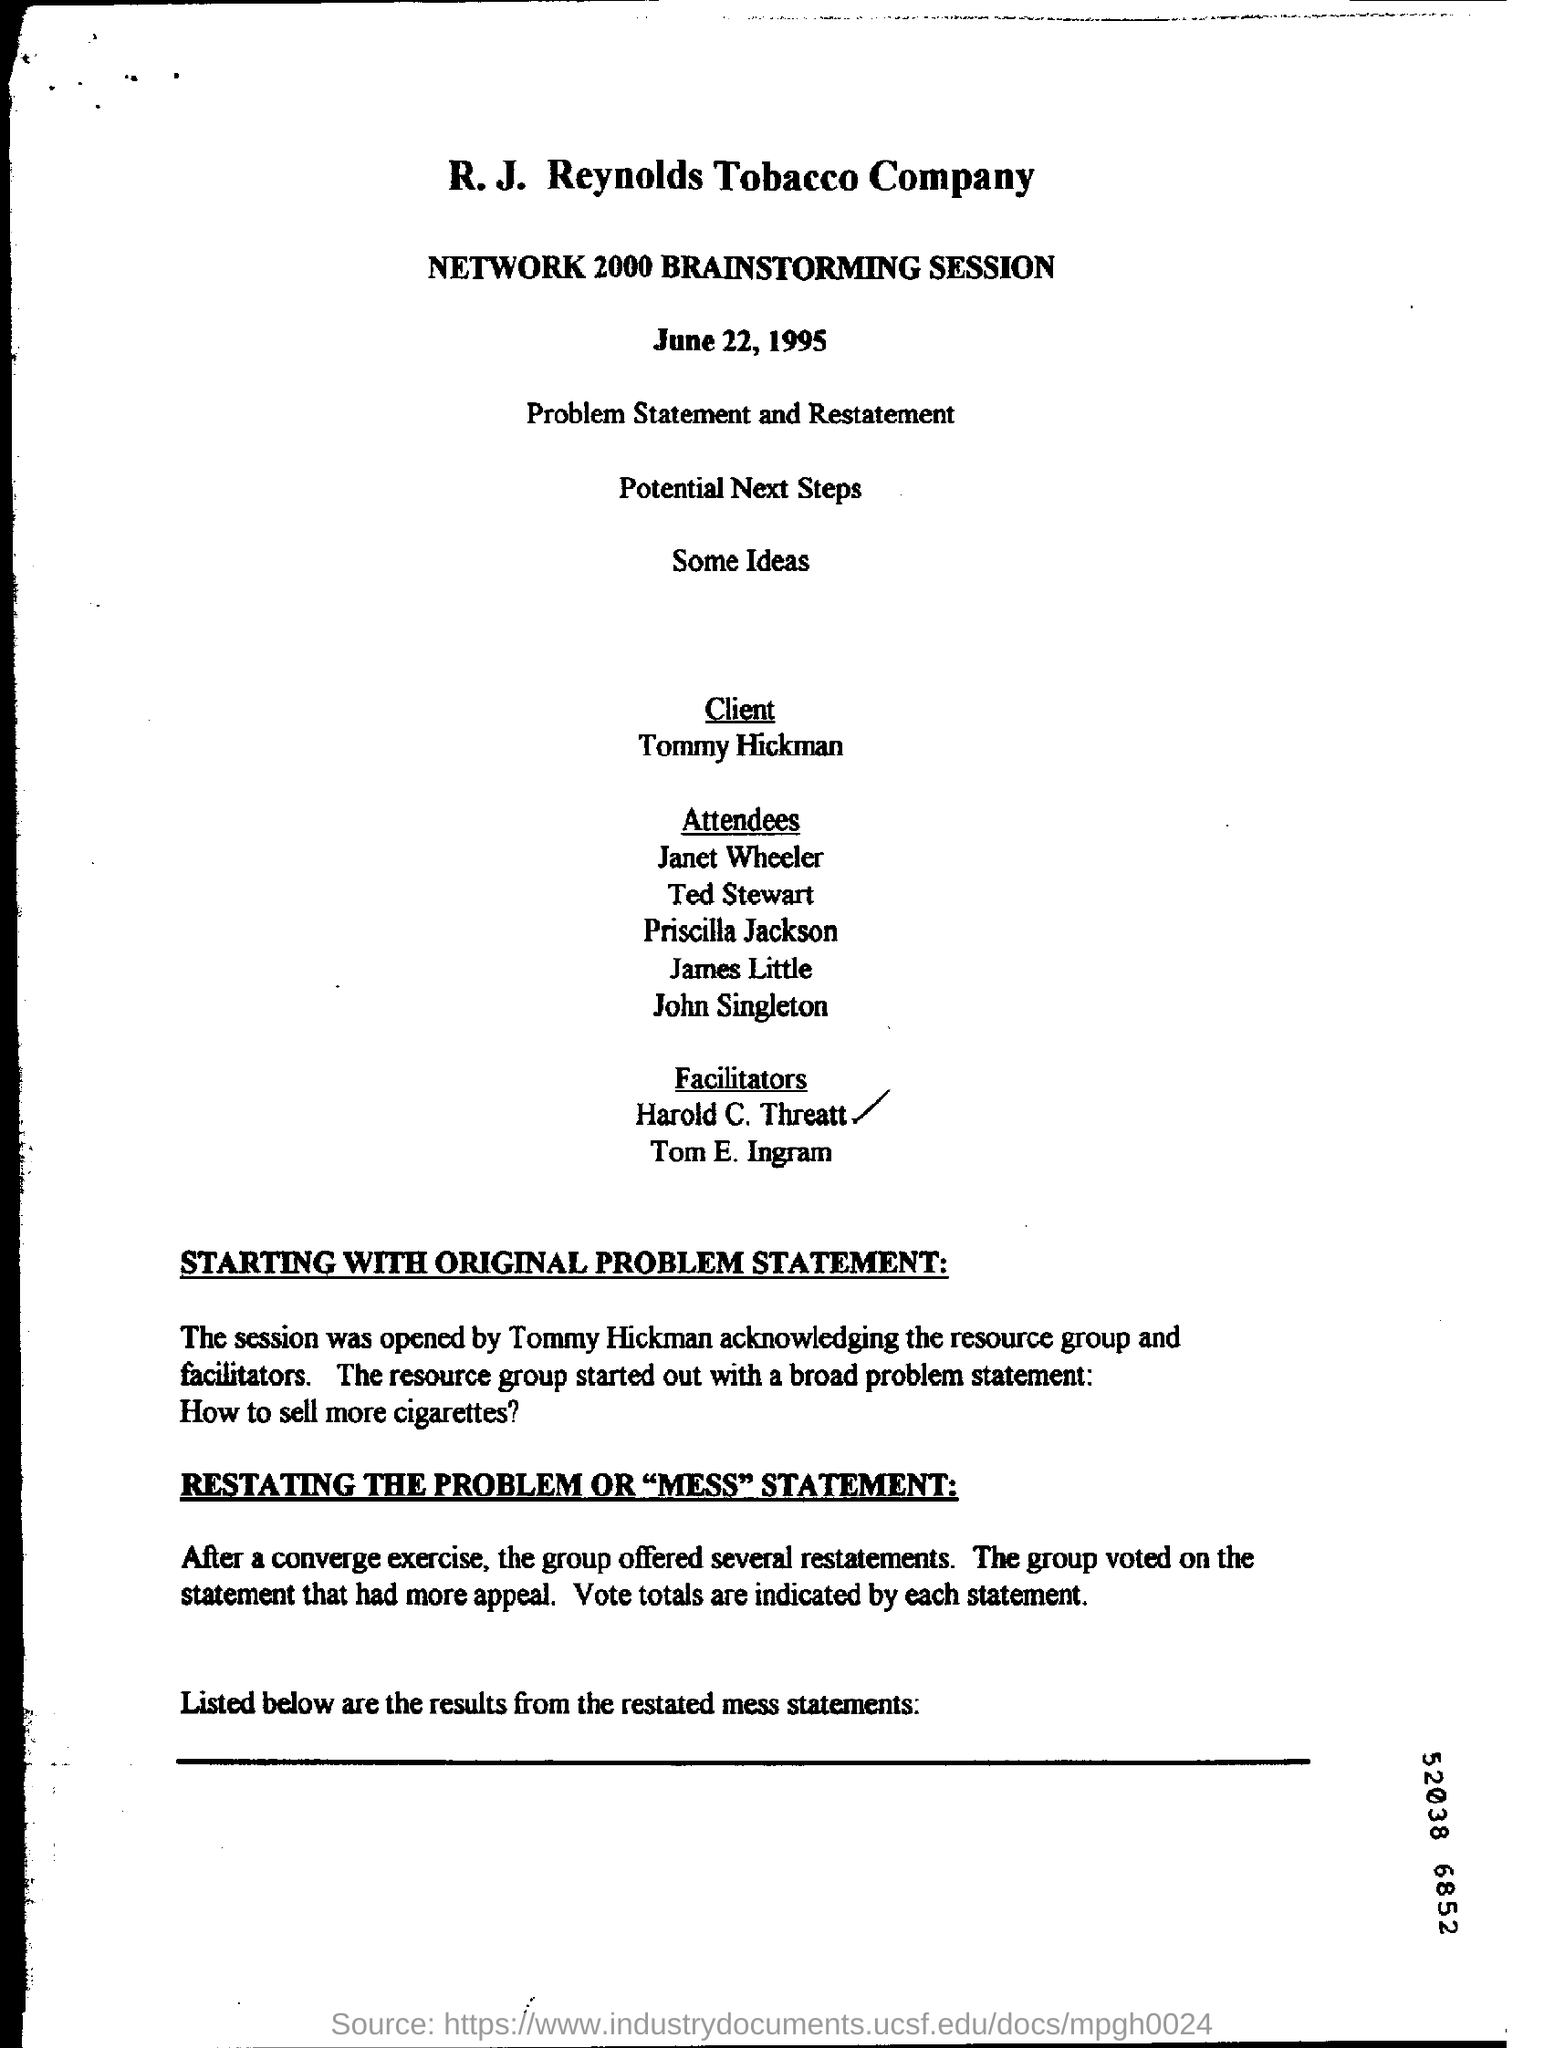Who is the client of tobacco company?
Make the answer very short. Tommy Hickman. What is the name of the session?
Your response must be concise. Network 2000 brainstorming session. 